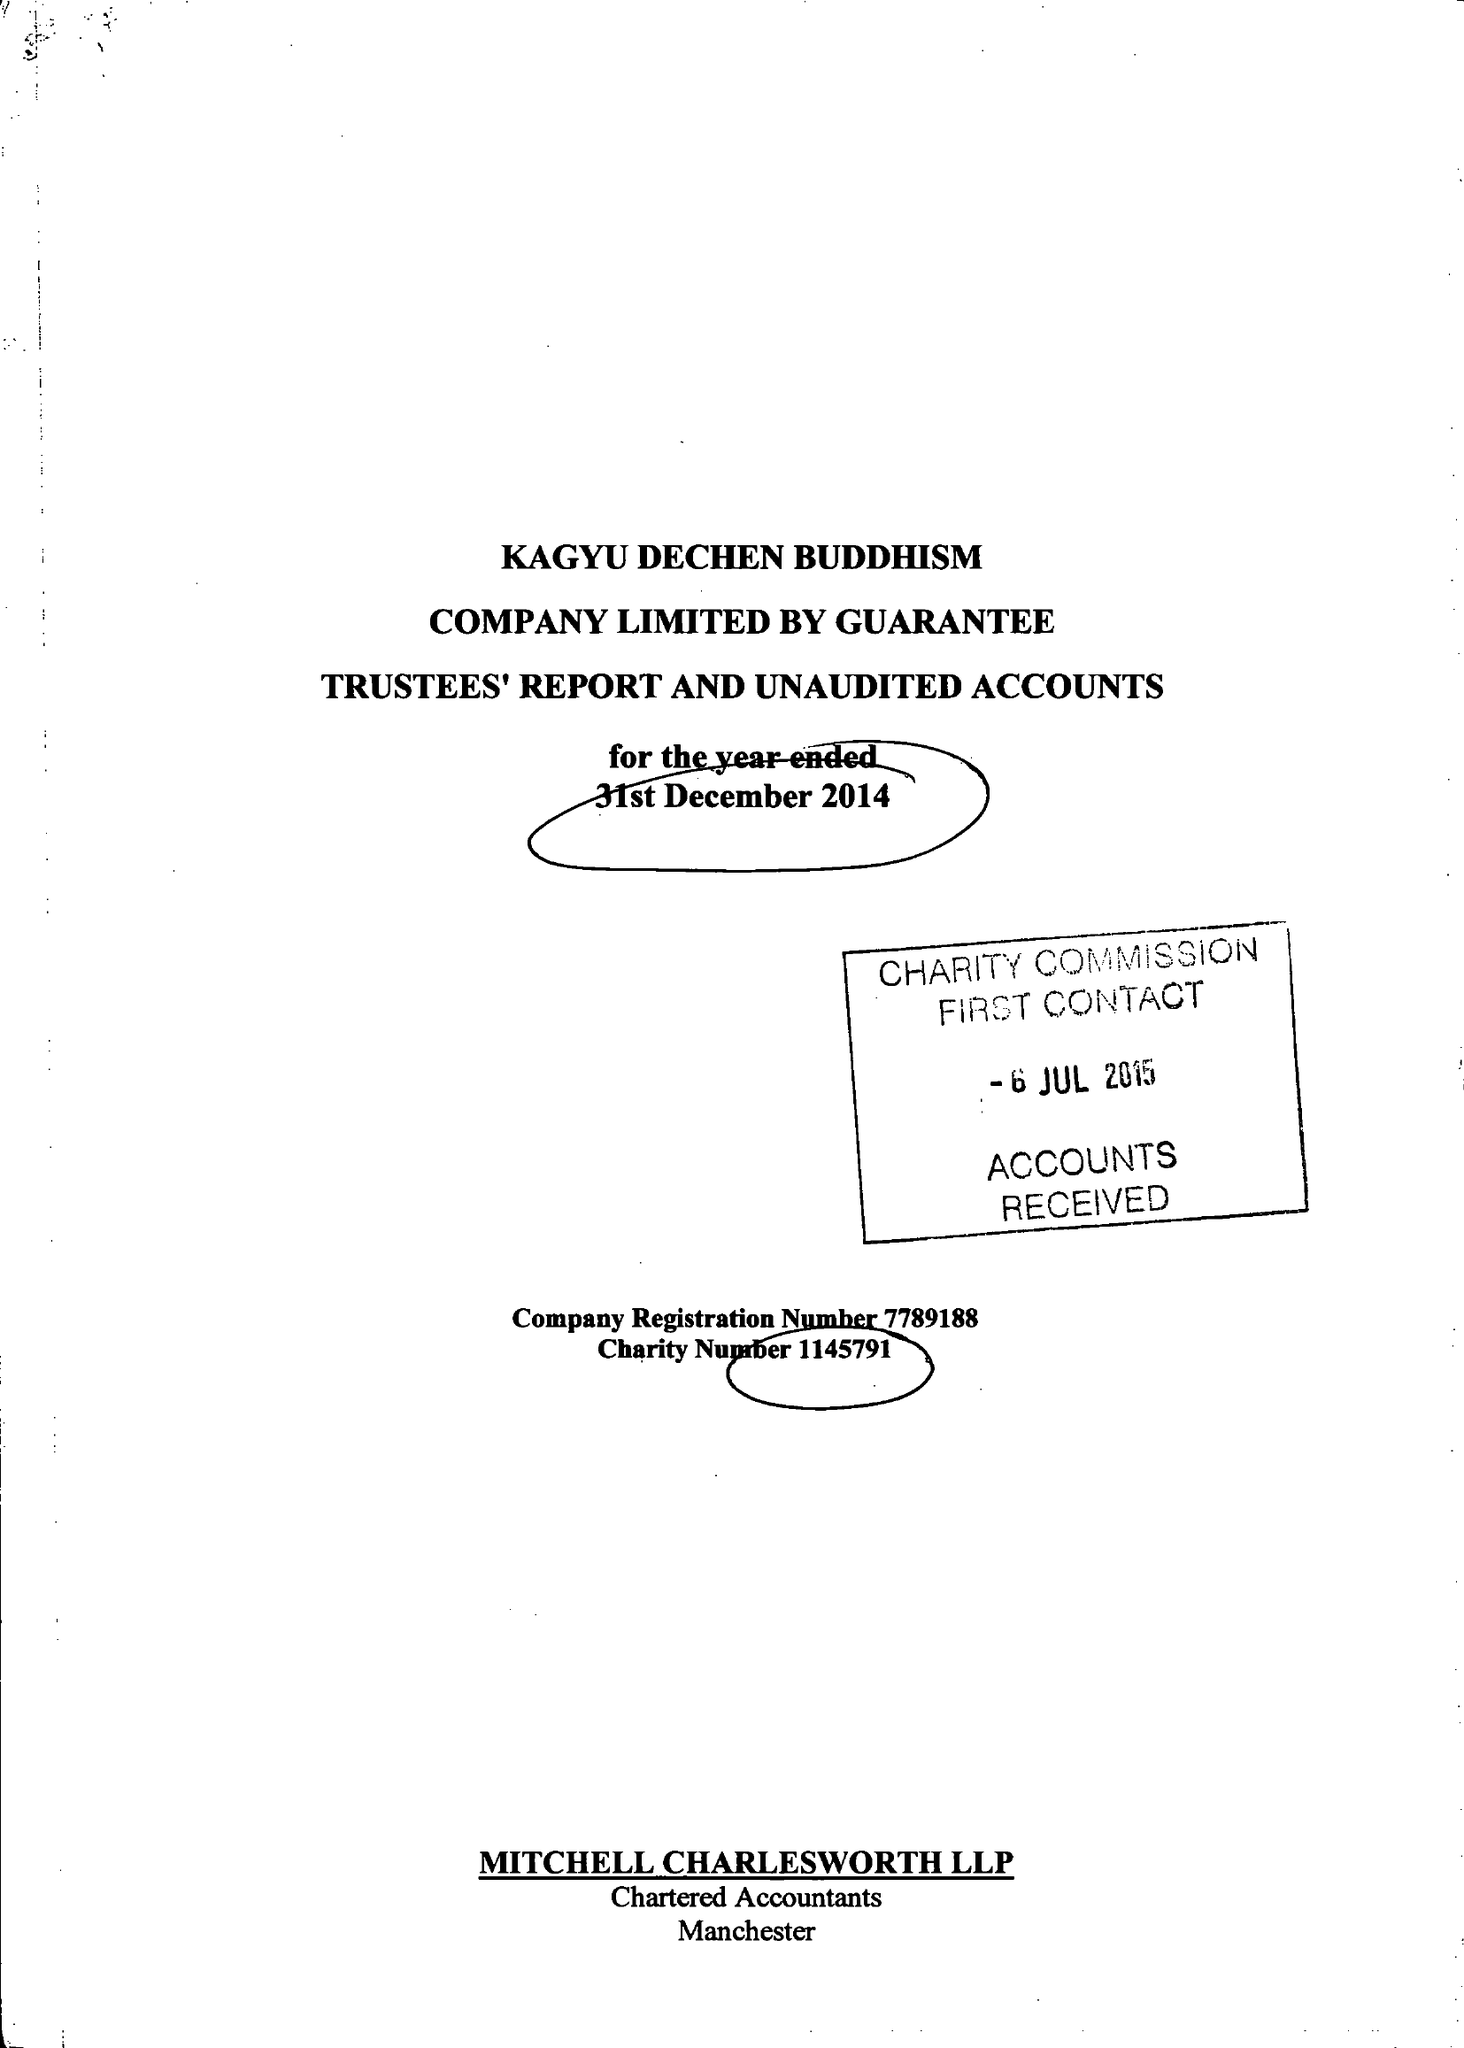What is the value for the income_annually_in_british_pounds?
Answer the question using a single word or phrase. 137744.00 